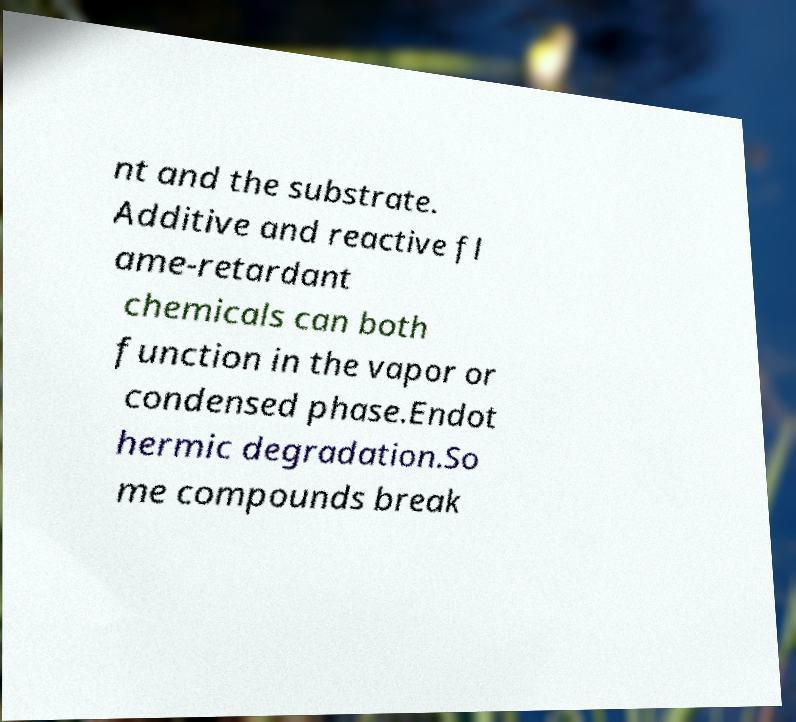Please read and relay the text visible in this image. What does it say? nt and the substrate. Additive and reactive fl ame-retardant chemicals can both function in the vapor or condensed phase.Endot hermic degradation.So me compounds break 